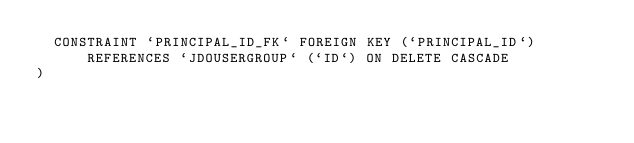Convert code to text. <code><loc_0><loc_0><loc_500><loc_500><_SQL_>  CONSTRAINT `PRINCIPAL_ID_FK` FOREIGN KEY (`PRINCIPAL_ID`) REFERENCES `JDOUSERGROUP` (`ID`) ON DELETE CASCADE
)
</code> 